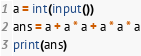Convert code to text. <code><loc_0><loc_0><loc_500><loc_500><_Python_>a = int(input())
ans = a + a * a + a * a * a
print(ans)</code> 